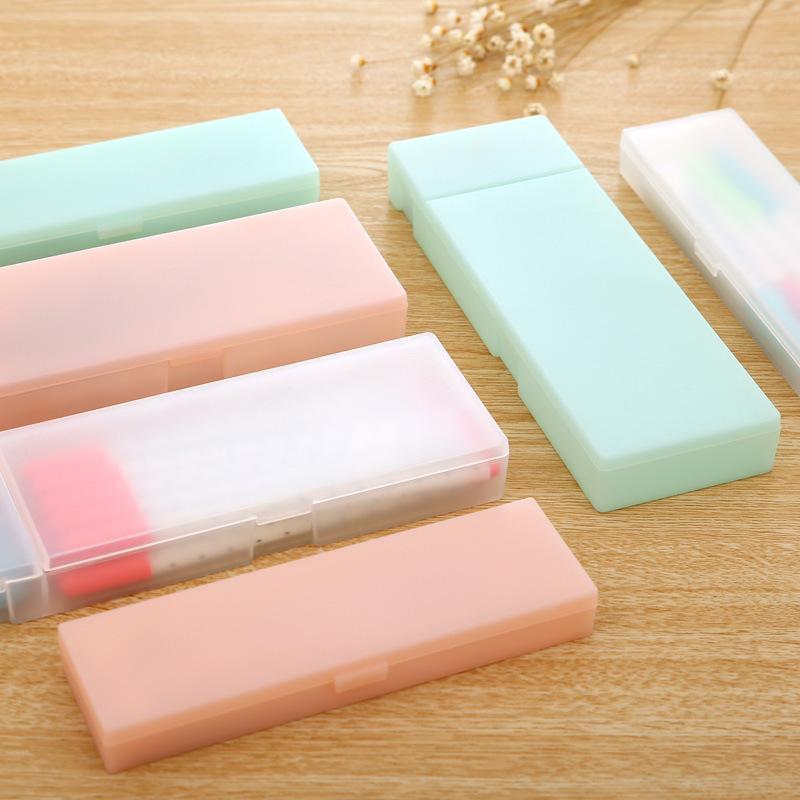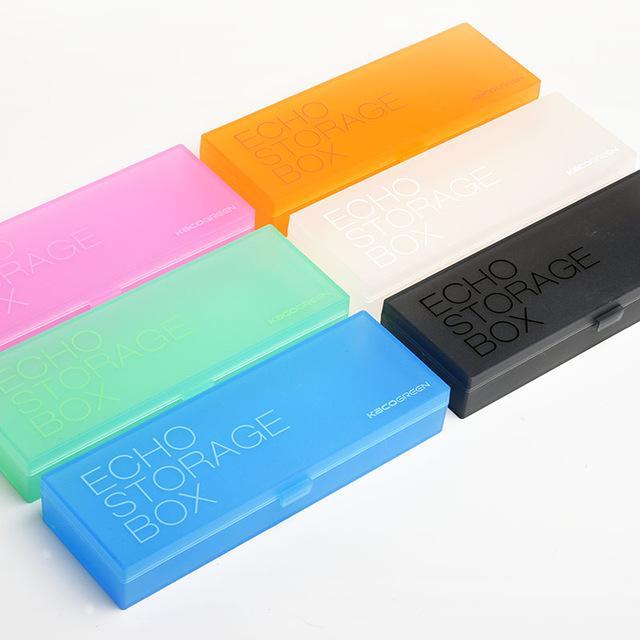The first image is the image on the left, the second image is the image on the right. For the images displayed, is the sentence "The pencil cases are open." factually correct? Answer yes or no. No. The first image is the image on the left, the second image is the image on the right. Assess this claim about the two images: "Each image includes an open plastic rectangular case filled with supplies, and at least one of the open cases pictured is greenish.". Correct or not? Answer yes or no. No. 